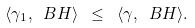Convert formula to latex. <formula><loc_0><loc_0><loc_500><loc_500>\langle \gamma _ { 1 } , \ B H \rangle \ \leq \ \langle \gamma , \ B H \rangle .</formula> 